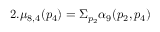<formula> <loc_0><loc_0><loc_500><loc_500>2 . \mu _ { 8 , 4 } ( p _ { 4 } ) = \Sigma _ { p _ { 2 } } \alpha _ { 9 } ( p _ { 2 } , p _ { 4 } )</formula> 